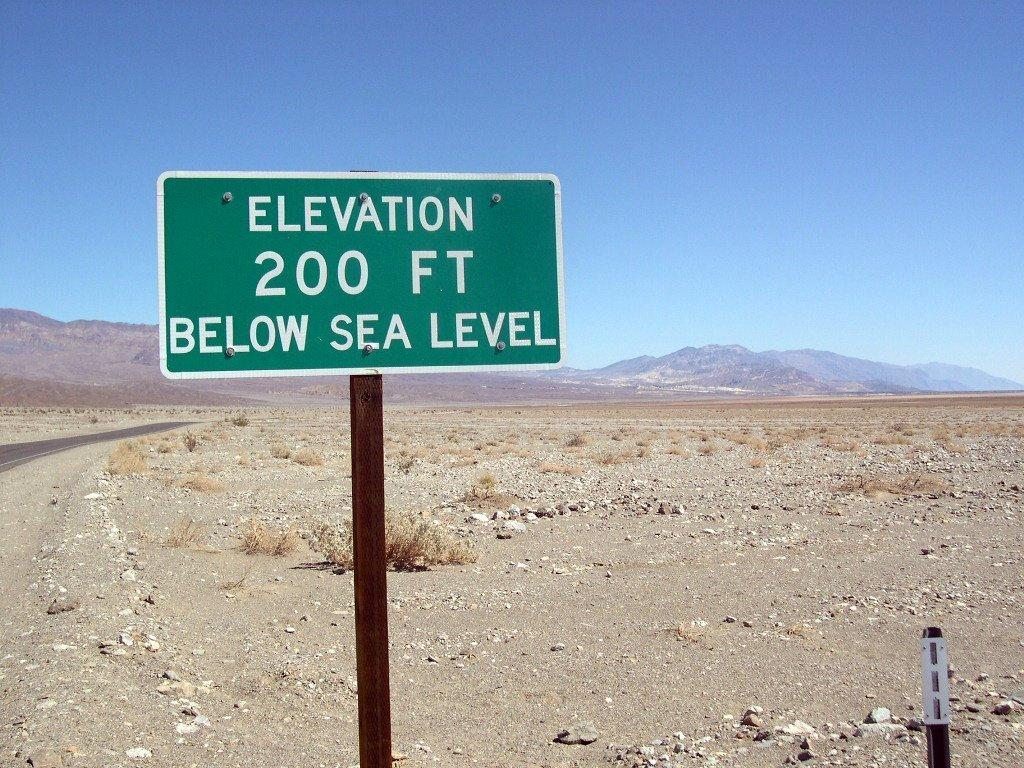<image>
Provide a brief description of the given image. A green adn white street sign has the text elevation 200 fet below sea level on it. 